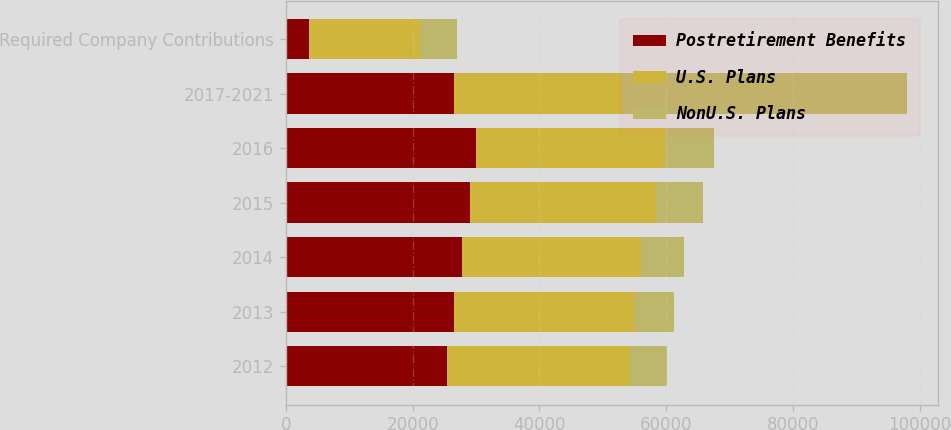<chart> <loc_0><loc_0><loc_500><loc_500><stacked_bar_chart><ecel><fcel>2012<fcel>2013<fcel>2014<fcel>2015<fcel>2016<fcel>2017-2021<fcel>Required Company Contributions<nl><fcel>Postretirement Benefits<fcel>25378<fcel>26527<fcel>27778<fcel>29110<fcel>30027<fcel>26527<fcel>3699<nl><fcel>U.S. Plans<fcel>28943<fcel>28331<fcel>28195<fcel>29344<fcel>29808<fcel>26527<fcel>17402<nl><fcel>NonU.S. Plans<fcel>5867<fcel>6380<fcel>6905<fcel>7359<fcel>7800<fcel>44959<fcel>5867<nl></chart> 